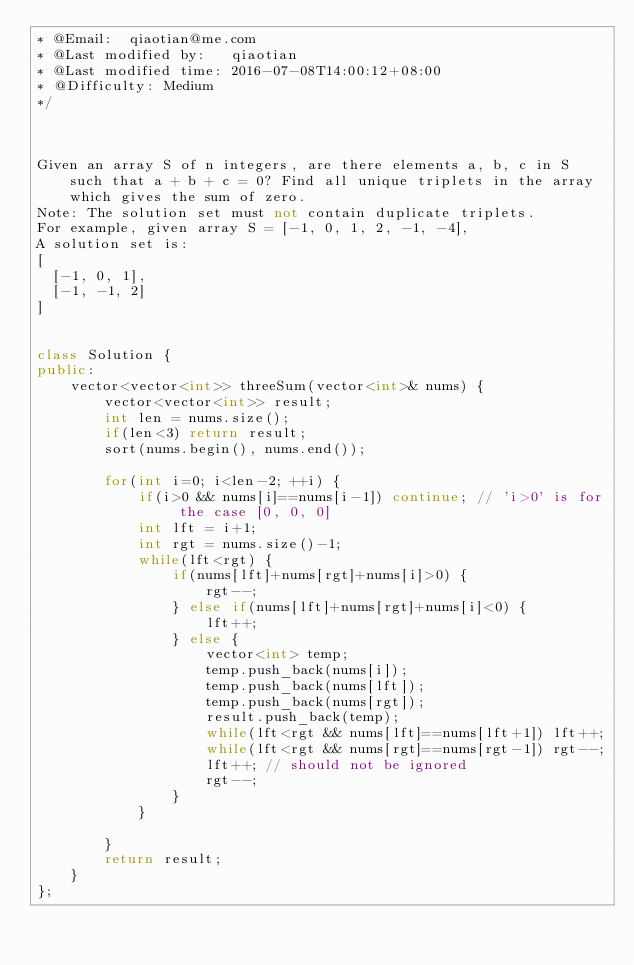Convert code to text. <code><loc_0><loc_0><loc_500><loc_500><_C++_>* @Email:  qiaotian@me.com
* @Last modified by:   qiaotian
* @Last modified time: 2016-07-08T14:00:12+08:00
* @Difficulty: Medium
*/



Given an array S of n integers, are there elements a, b, c in S such that a + b + c = 0? Find all unique triplets in the array which gives the sum of zero.
Note: The solution set must not contain duplicate triplets.
For example, given array S = [-1, 0, 1, 2, -1, -4],
A solution set is:
[
  [-1, 0, 1],
  [-1, -1, 2]
]


class Solution {
public:
    vector<vector<int>> threeSum(vector<int>& nums) {
        vector<vector<int>> result;
        int len = nums.size();
        if(len<3) return result;
        sort(nums.begin(), nums.end());

        for(int i=0; i<len-2; ++i) {
            if(i>0 && nums[i]==nums[i-1]) continue; // 'i>0' is for the case [0, 0, 0]
            int lft = i+1;
            int rgt = nums.size()-1;
            while(lft<rgt) {
                if(nums[lft]+nums[rgt]+nums[i]>0) {
                    rgt--;
                } else if(nums[lft]+nums[rgt]+nums[i]<0) {
                    lft++;
                } else {
                    vector<int> temp;
                    temp.push_back(nums[i]);
                    temp.push_back(nums[lft]);
                    temp.push_back(nums[rgt]);
                    result.push_back(temp);
                    while(lft<rgt && nums[lft]==nums[lft+1]) lft++;
                    while(lft<rgt && nums[rgt]==nums[rgt-1]) rgt--;
                    lft++; // should not be ignored
                    rgt--;
                }
            }

        }
        return result;
    }
};
</code> 